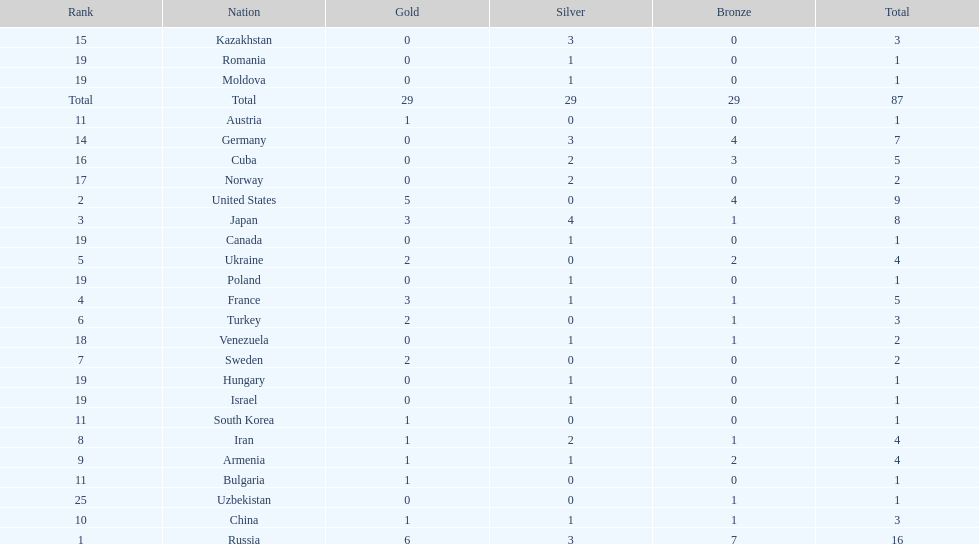Which country won only one medal, a bronze medal? Uzbekistan. 